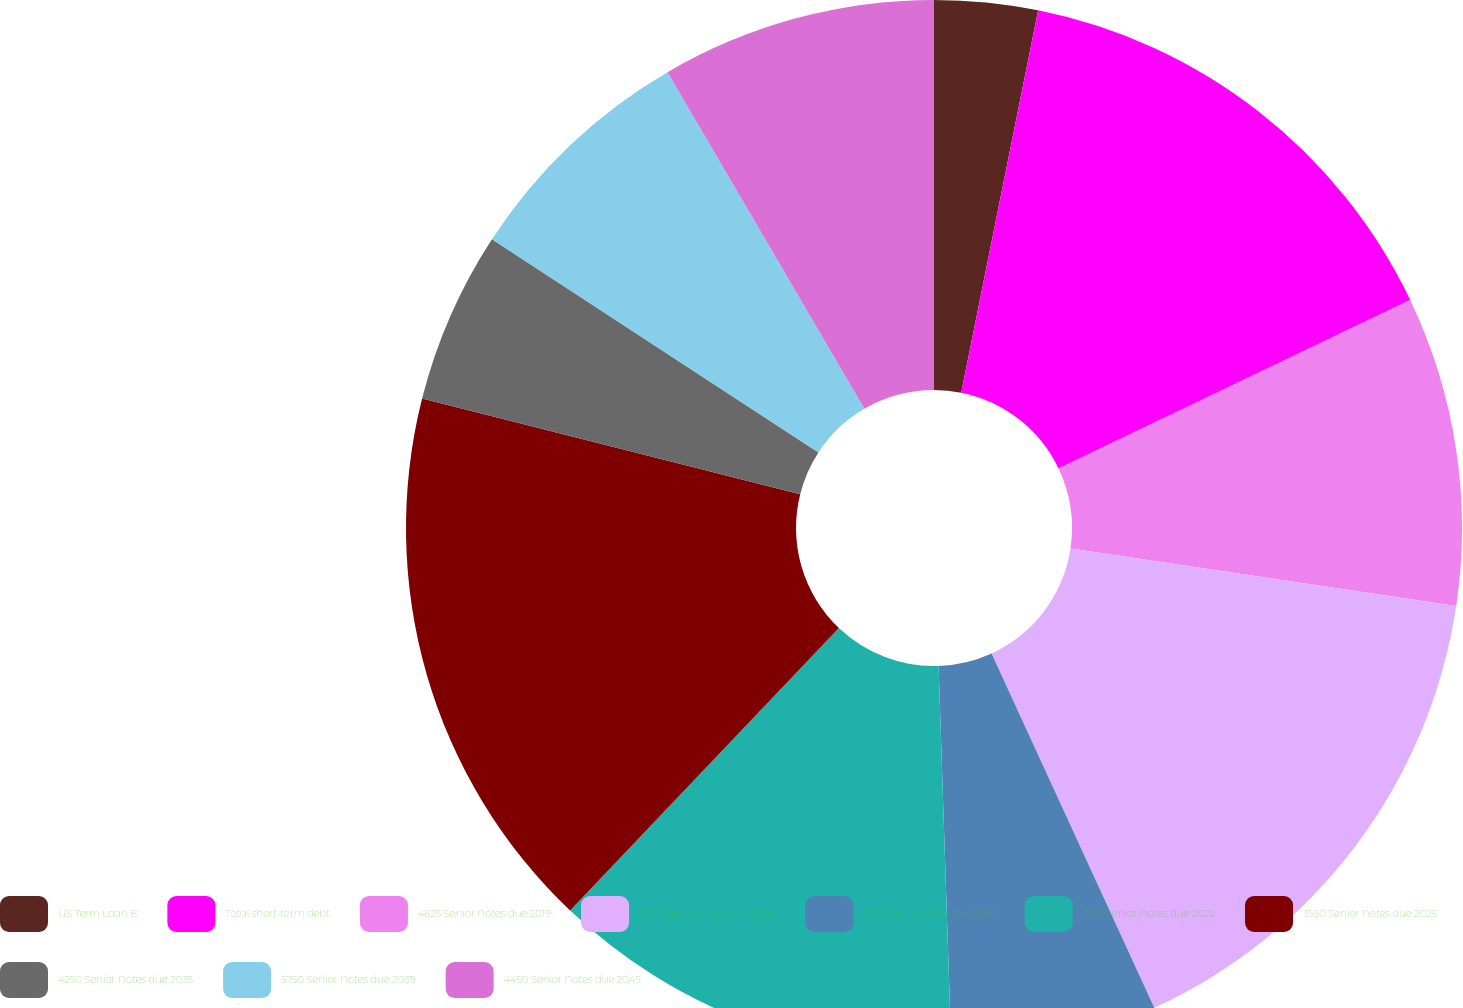<chart> <loc_0><loc_0><loc_500><loc_500><pie_chart><fcel>US Term Loan B<fcel>Total short-term debt<fcel>4625 Senior Notes due 2019<fcel>2700 Senior Notes due 2020<fcel>3375 Senior Notes due 2021<fcel>3150 Senior Notes due 2022<fcel>3550 Senior Notes due 2025<fcel>4250 Senior Notes due 2035<fcel>5750 Senior Notes due 2039<fcel>4450 Senior Notes due 2045<nl><fcel>3.16%<fcel>14.73%<fcel>9.47%<fcel>15.79%<fcel>6.32%<fcel>12.63%<fcel>16.84%<fcel>5.27%<fcel>7.37%<fcel>8.42%<nl></chart> 